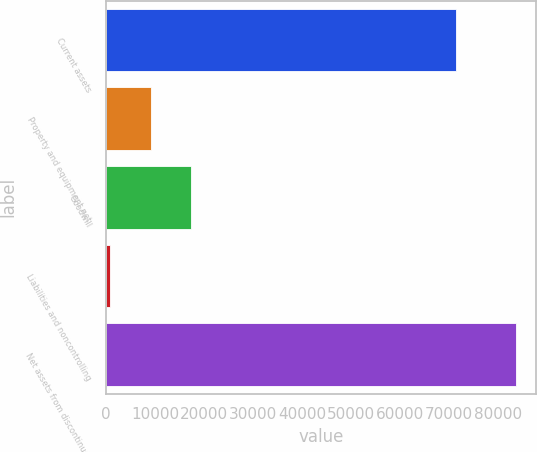Convert chart to OTSL. <chart><loc_0><loc_0><loc_500><loc_500><bar_chart><fcel>Current assets<fcel>Property and equipment net<fcel>Goodwill<fcel>Liabilities and noncontrolling<fcel>Net assets from discontinued<nl><fcel>71384<fcel>9125.4<fcel>17414.8<fcel>836<fcel>83730<nl></chart> 